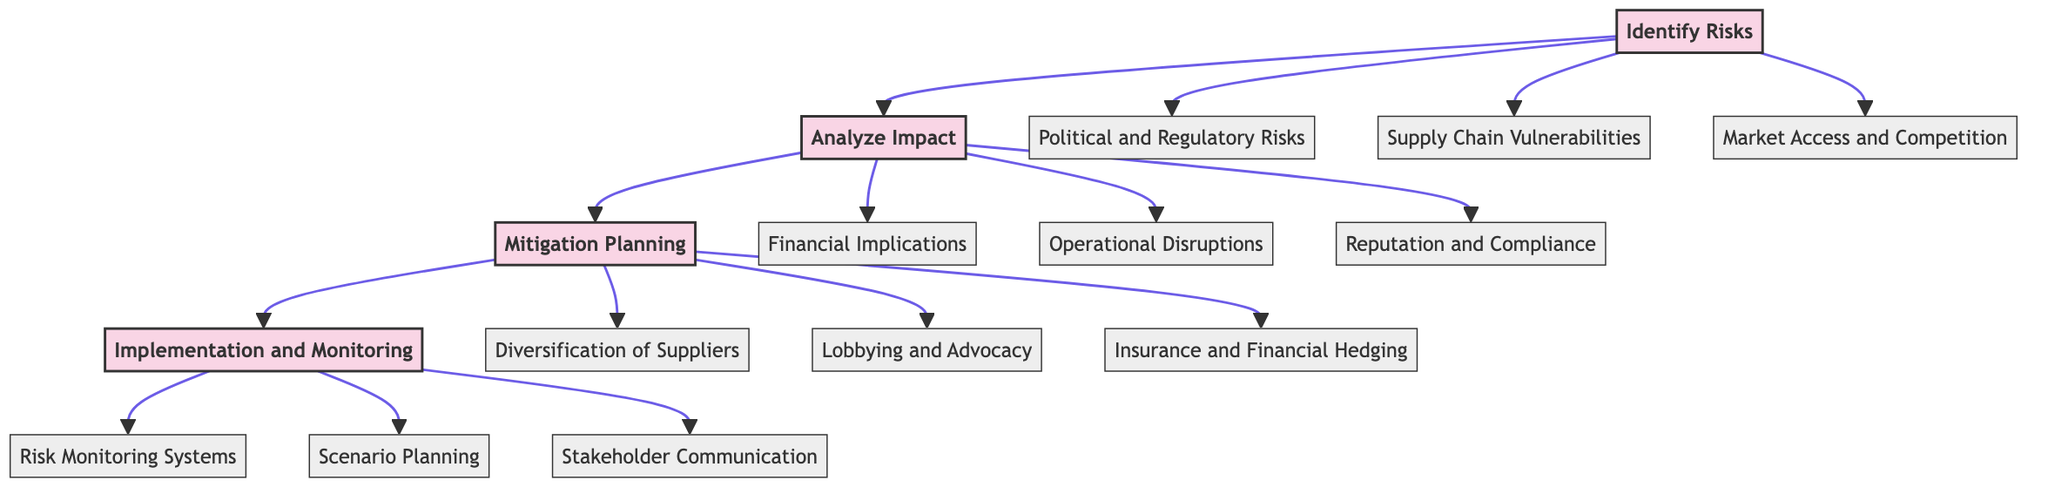What is the first stage in the pathway? The diagram indicates that the first stage is labeled "Identify Risks." This is directly stated at the top of the flowchart and initiates the sequence of actions in risk management.
Answer: Identify Risks How many elements are in the "Analyze Impact" stage? By reviewing the "Analyze Impact" stage, we can see it comprises three elements: "Financial Implications," "Operational Disruptions," and "Reputation and Compliance." Counting them gives us the total of three.
Answer: 3 What follows "Mitigation Planning" in the pathway? The diagram shows that "Implementation and Monitoring" comes directly after "Mitigation Planning," indicating the flow of actions in the risk management process.
Answer: Implementation and Monitoring Which element addresses supply chain issues? The element "Supply Chain Vulnerabilities" in the "Identify Risks" stage specifically addresses concerns related to supply chain reliability and resilience. It is explicitly mentioned as part of the risks to identify.
Answer: Supply Chain Vulnerabilities How many total stages are there in the diagram? The diagram illustrates four distinct stages: "Identify Risks," "Analyze Impact," "Mitigation Planning," and "Implementation and Monitoring." Counting each of these stages gives a total of four.
Answer: 4 What do the "Insurance and Financial Hedging" strategies aim to manage? The element "Insurance and Financial Hedging," which falls under "Mitigation Planning," is aimed at managing financial losses due to trade disruptions. This is explicitly stated in the description of this element.
Answer: Financial losses Which two elements in "Implementation and Monitoring" involve preparing for risks? The elements "Scenario Planning" and "Risk Monitoring Systems" help prepare for risks by ensuring readiness for different scenarios and continuously tracking risk factors, respectively. Analyzing their descriptions makes this clear.
Answer: Scenario Planning, Risk Monitoring Systems What is the main focus of the "Analyze Impact" stage? The focus of the "Analyze Impact" stage is to quantify the effects of identified risks, as captured by the descriptions of its elements, mainly through financial, operational, and reputational considerations.
Answer: Quantifying effects 